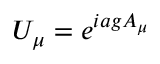Convert formula to latex. <formula><loc_0><loc_0><loc_500><loc_500>U _ { \mu } = e ^ { i a g A _ { \mu } }</formula> 